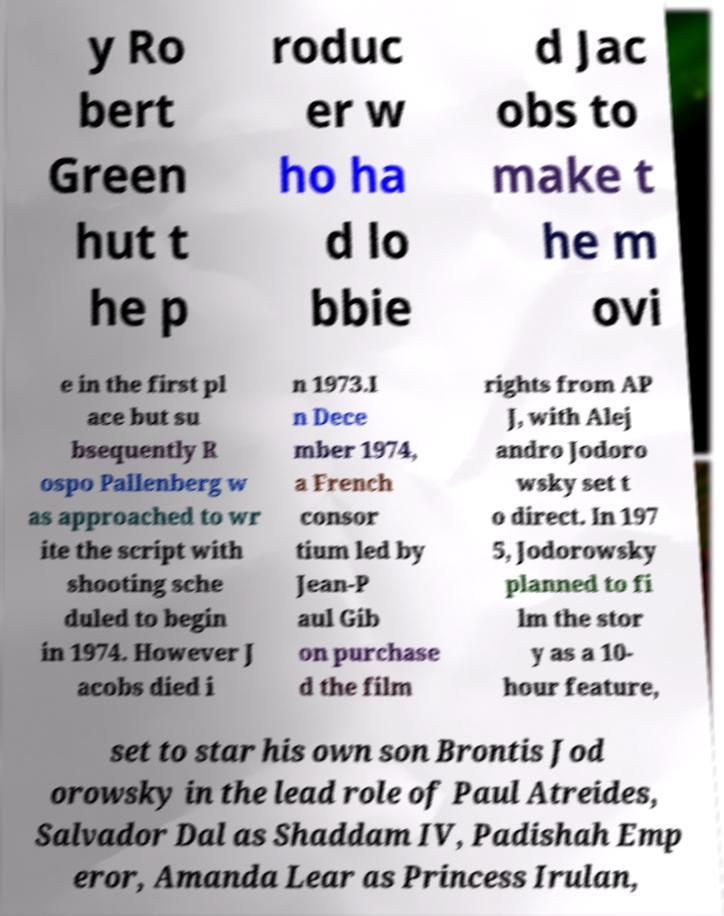Please read and relay the text visible in this image. What does it say? y Ro bert Green hut t he p roduc er w ho ha d lo bbie d Jac obs to make t he m ovi e in the first pl ace but su bsequently R ospo Pallenberg w as approached to wr ite the script with shooting sche duled to begin in 1974. However J acobs died i n 1973.I n Dece mber 1974, a French consor tium led by Jean-P aul Gib on purchase d the film rights from AP J, with Alej andro Jodoro wsky set t o direct. In 197 5, Jodorowsky planned to fi lm the stor y as a 10- hour feature, set to star his own son Brontis Jod orowsky in the lead role of Paul Atreides, Salvador Dal as Shaddam IV, Padishah Emp eror, Amanda Lear as Princess Irulan, 